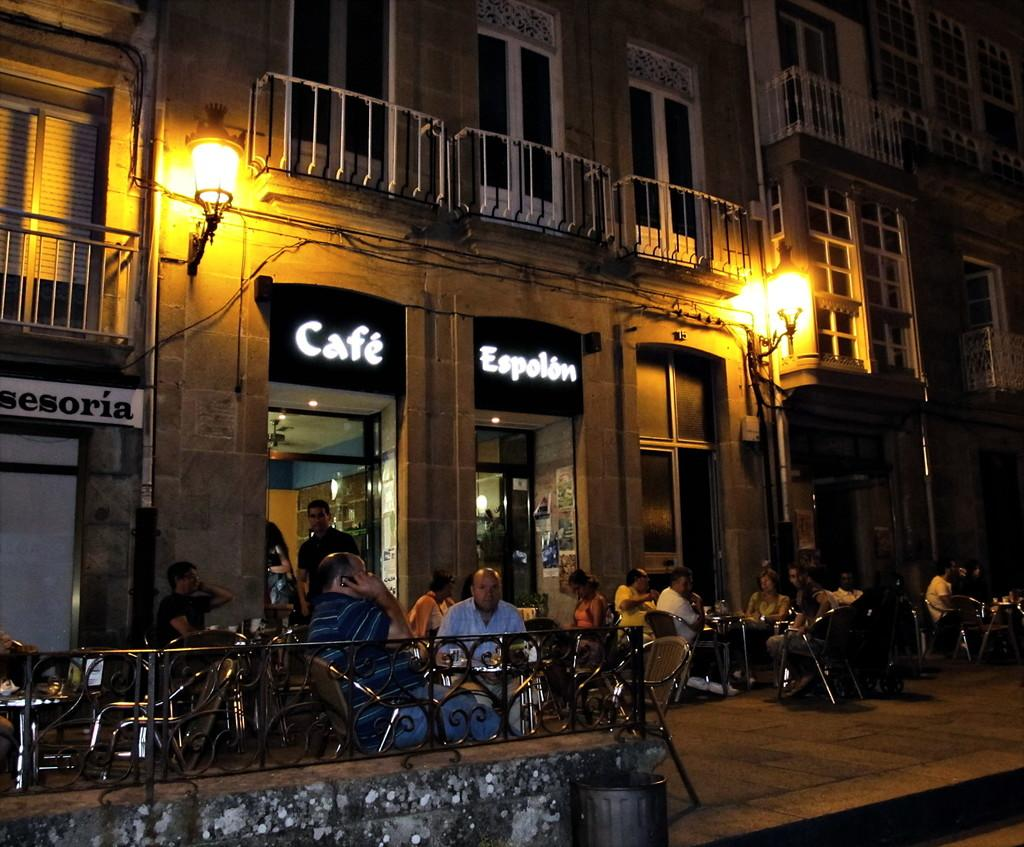<image>
Offer a succinct explanation of the picture presented. People sitting outdoors in front of the Cafe Espolon 